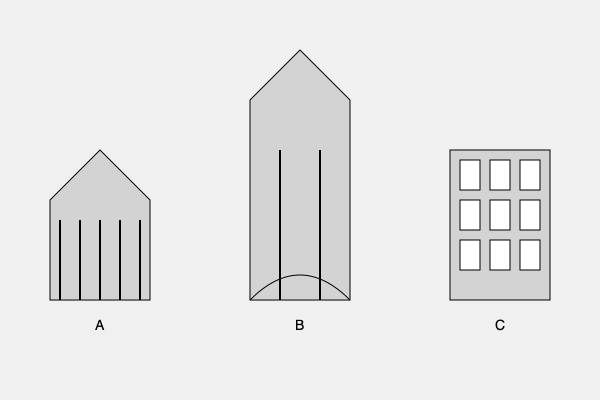As an author of historical fiction, you often need to describe architectural styles accurately. Based on the simplified sketches above, which building style is characterized by pointed arches, tall spires, and an emphasis on vertical lines? To answer this question, let's analyze each building style represented in the sketches:

1. Building A:
   - Triangular pediment
   - Horizontal emphasis
   - Evenly spaced columns
   These features are typical of Ancient Greek architecture, particularly temples.

2. Building B:
   - Tall, vertical structure
   - Pointed arch visible in the doorway
   - Emphasis on height and vertical lines
   - Spire-like top
   These characteristics are distinctive of Gothic architecture, commonly seen in cathedrals.

3. Building C:
   - Rectangular shape
   - Symmetrical layout of windows
   - Horizontal emphasis
   - Lack of ornate decorations
   These features are indicative of Renaissance architecture, often seen in palaces and civic buildings.

The question asks about a style characterized by pointed arches, tall spires, and an emphasis on vertical lines. Among the three options, only Building B (Gothic) exhibits these specific traits.

Gothic architecture, which flourished during the High and Late Middle Ages, is known for its:
- Pointed arches (visible in the doorway)
- Tall spires (the top of the building)
- Strong emphasis on vertical lines (overall structure)
- Great height (tallest among the three buildings shown)

These features were designed to draw the eye upward, symbolizing humanity's aspiration towards the heavens, and were commonly used in the construction of cathedrals and churches.
Answer: Gothic (Building B) 